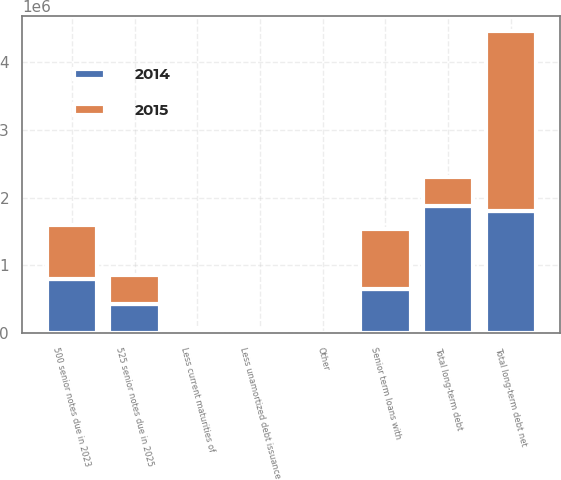Convert chart. <chart><loc_0><loc_0><loc_500><loc_500><stacked_bar_chart><ecel><fcel>Senior term loans with<fcel>500 senior notes due in 2023<fcel>525 senior notes due in 2025<fcel>Other<fcel>Total long-term debt<fcel>Less current maturities of<fcel>Less unamortized debt issuance<fcel>Total long-term debt net<nl><fcel>2015<fcel>888125<fcel>800000<fcel>426682<fcel>63<fcel>426813<fcel>34428<fcel>30899<fcel>2.64511e+06<nl><fcel>2014<fcel>645613<fcel>800000<fcel>426813<fcel>2783<fcel>1.87521e+06<fcel>42407<fcel>24197<fcel>1.8086e+06<nl></chart> 